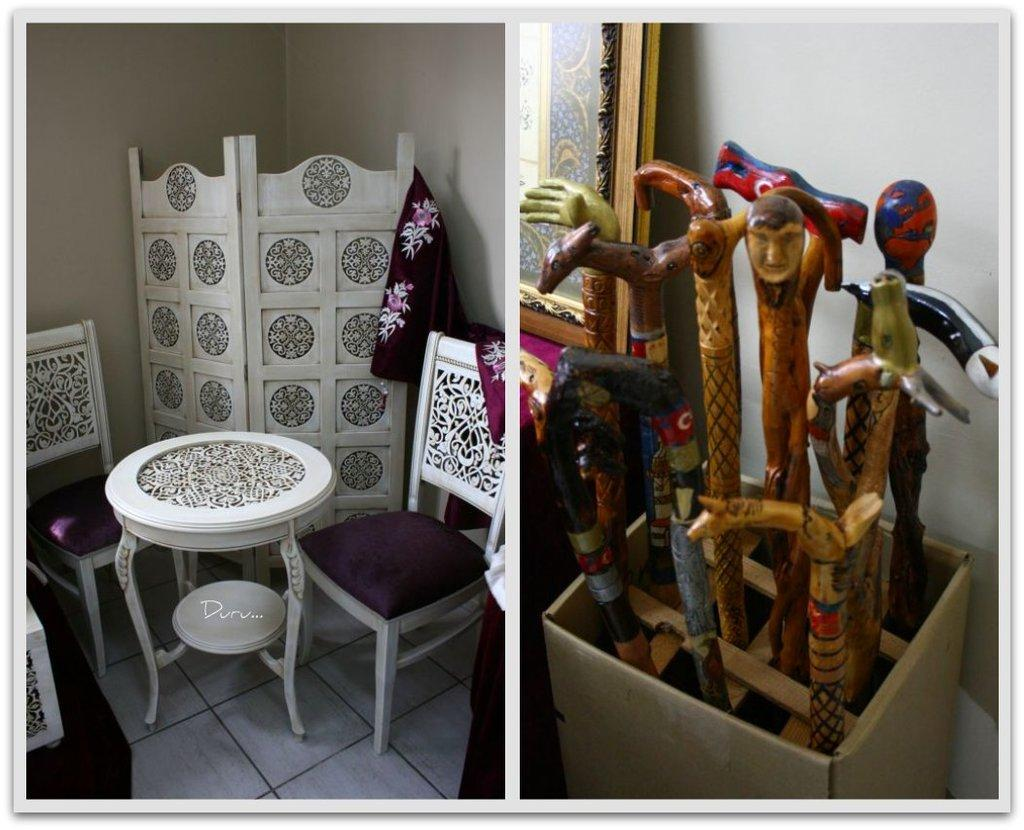What type of furniture is present in the image? There are chairs and a table in the image. What else can be seen in the image besides the furniture? There is a container and sticks in the image. What is the name of the person sitting on the chair in the image? There is no person present in the image, so it is not possible to determine their name. 